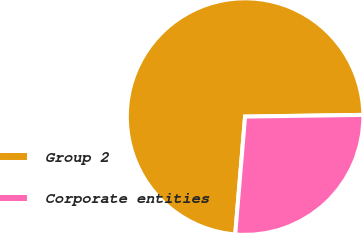Convert chart. <chart><loc_0><loc_0><loc_500><loc_500><pie_chart><fcel>Group 2<fcel>Corporate entities<nl><fcel>73.44%<fcel>26.56%<nl></chart> 